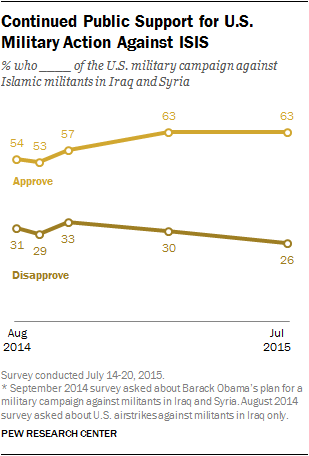List a handful of essential elements in this visual. The average score in the "Approve" data set is 58. In July 2015, the data consisted of two values: 63 and 26. 